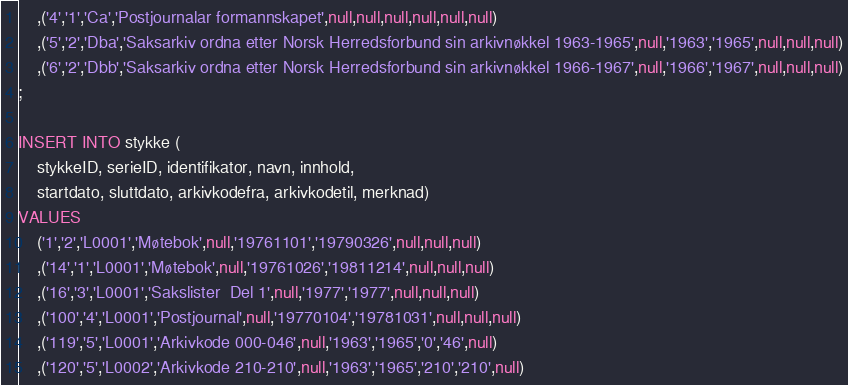Convert code to text. <code><loc_0><loc_0><loc_500><loc_500><_SQL_>	,('4','1','Ca','Postjournalar formannskapet',null,null,null,null,null,null)
	,('5','2','Dba','Saksarkiv ordna etter Norsk Herredsforbund sin arkivnøkkel 1963-1965',null,'1963','1965',null,null,null)
	,('6','2','Dbb','Saksarkiv ordna etter Norsk Herredsforbund sin arkivnøkkel 1966-1967',null,'1966','1967',null,null,null)
;

INSERT INTO stykke (
	stykkeID, serieID, identifikator, navn, innhold, 
	startdato, sluttdato, arkivkodefra, arkivkodetil, merknad)
VALUES
	('1','2','L0001','Møtebok',null,'19761101','19790326',null,null,null)
	,('14','1','L0001','Møtebok',null,'19761026','19811214',null,null,null)
	,('16','3','L0001','Sakslister  Del 1',null,'1977','1977',null,null,null)
	,('100','4','L0001','Postjournal',null,'19770104','19781031',null,null,null)
	,('119','5','L0001','Arkivkode 000-046',null,'1963','1965','0','46',null)
	,('120','5','L0002','Arkivkode 210-210',null,'1963','1965','210','210',null)</code> 